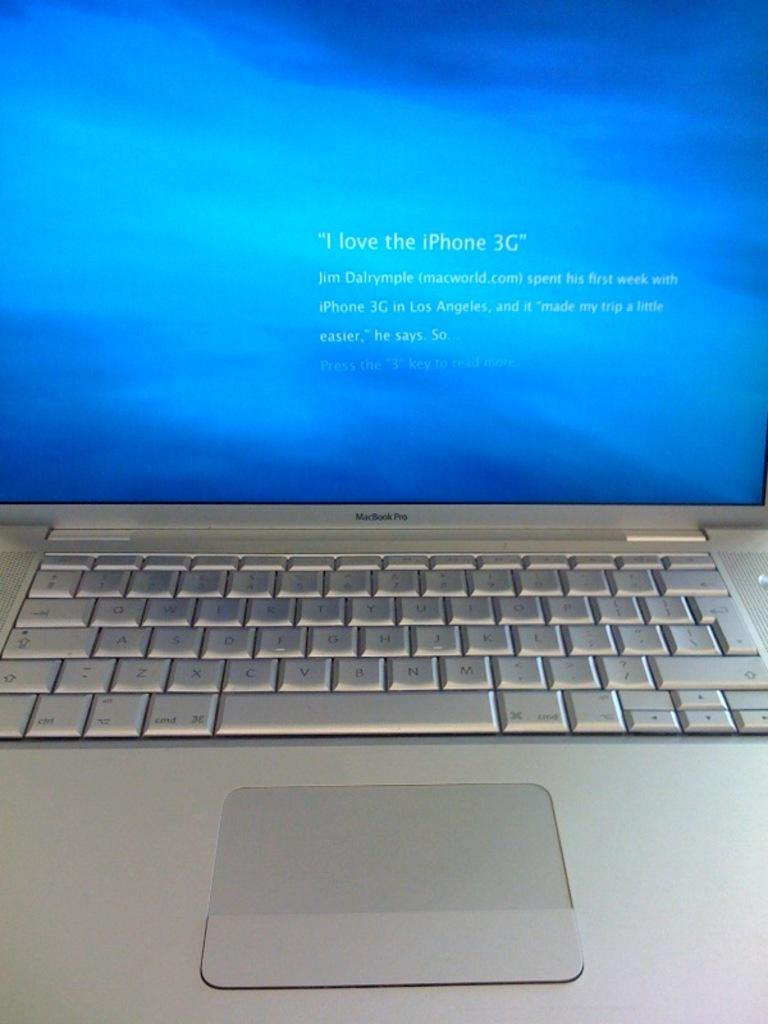Provide a one-sentence caption for the provided image. A mac laptop is shown with text that reads "I love iPhone 3G" on its monitor. 